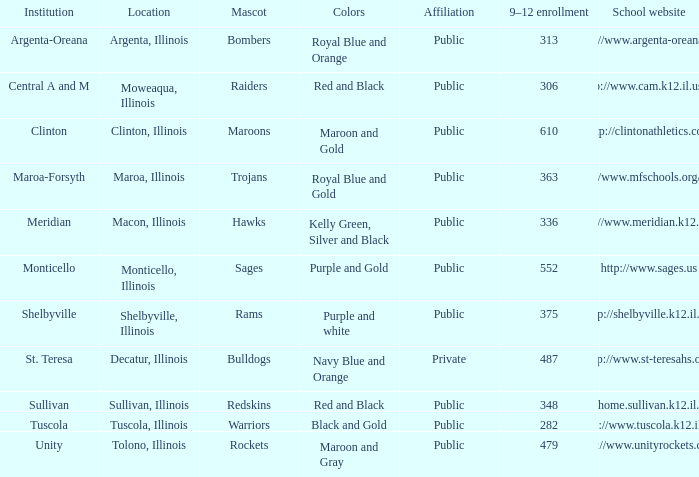What location has 363 students enrolled in the 9th to 12th grades? Maroa, Illinois. 